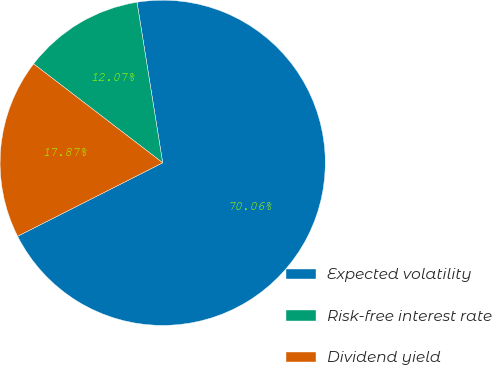Convert chart to OTSL. <chart><loc_0><loc_0><loc_500><loc_500><pie_chart><fcel>Expected volatility<fcel>Risk-free interest rate<fcel>Dividend yield<nl><fcel>70.06%<fcel>12.07%<fcel>17.87%<nl></chart> 